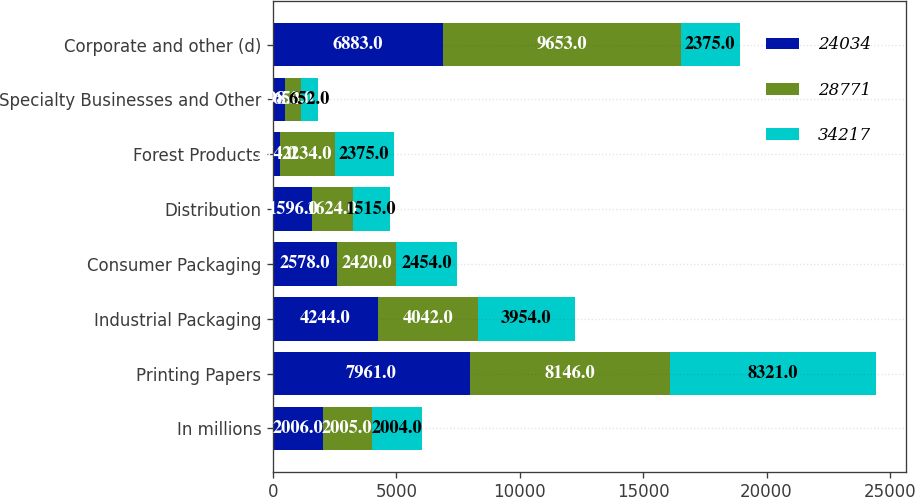Convert chart to OTSL. <chart><loc_0><loc_0><loc_500><loc_500><stacked_bar_chart><ecel><fcel>In millions<fcel>Printing Papers<fcel>Industrial Packaging<fcel>Consumer Packaging<fcel>Distribution<fcel>Forest Products<fcel>Specialty Businesses and Other<fcel>Corporate and other (d)<nl><fcel>24034<fcel>2006<fcel>7961<fcel>4244<fcel>2578<fcel>1596<fcel>274<fcel>498<fcel>6883<nl><fcel>28771<fcel>2005<fcel>8146<fcel>4042<fcel>2420<fcel>1624<fcel>2234<fcel>652<fcel>9653<nl><fcel>34217<fcel>2004<fcel>8321<fcel>3954<fcel>2454<fcel>1515<fcel>2375<fcel>652<fcel>2375<nl></chart> 